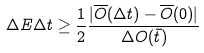<formula> <loc_0><loc_0><loc_500><loc_500>\Delta E \Delta t \geq \frac { 1 } { 2 } \frac { | \overline { O } ( \Delta t ) - \overline { O } ( 0 ) | } { \Delta O ( \bar { t } ) }</formula> 